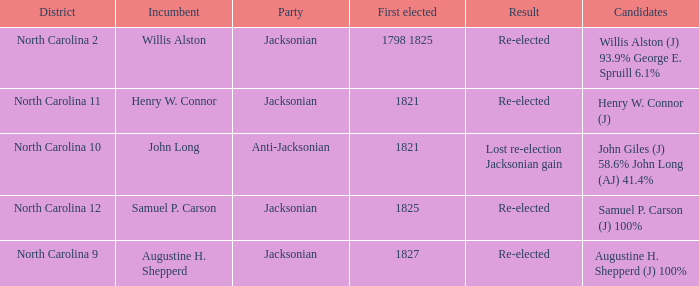Name the result for willis alston Re-elected. 